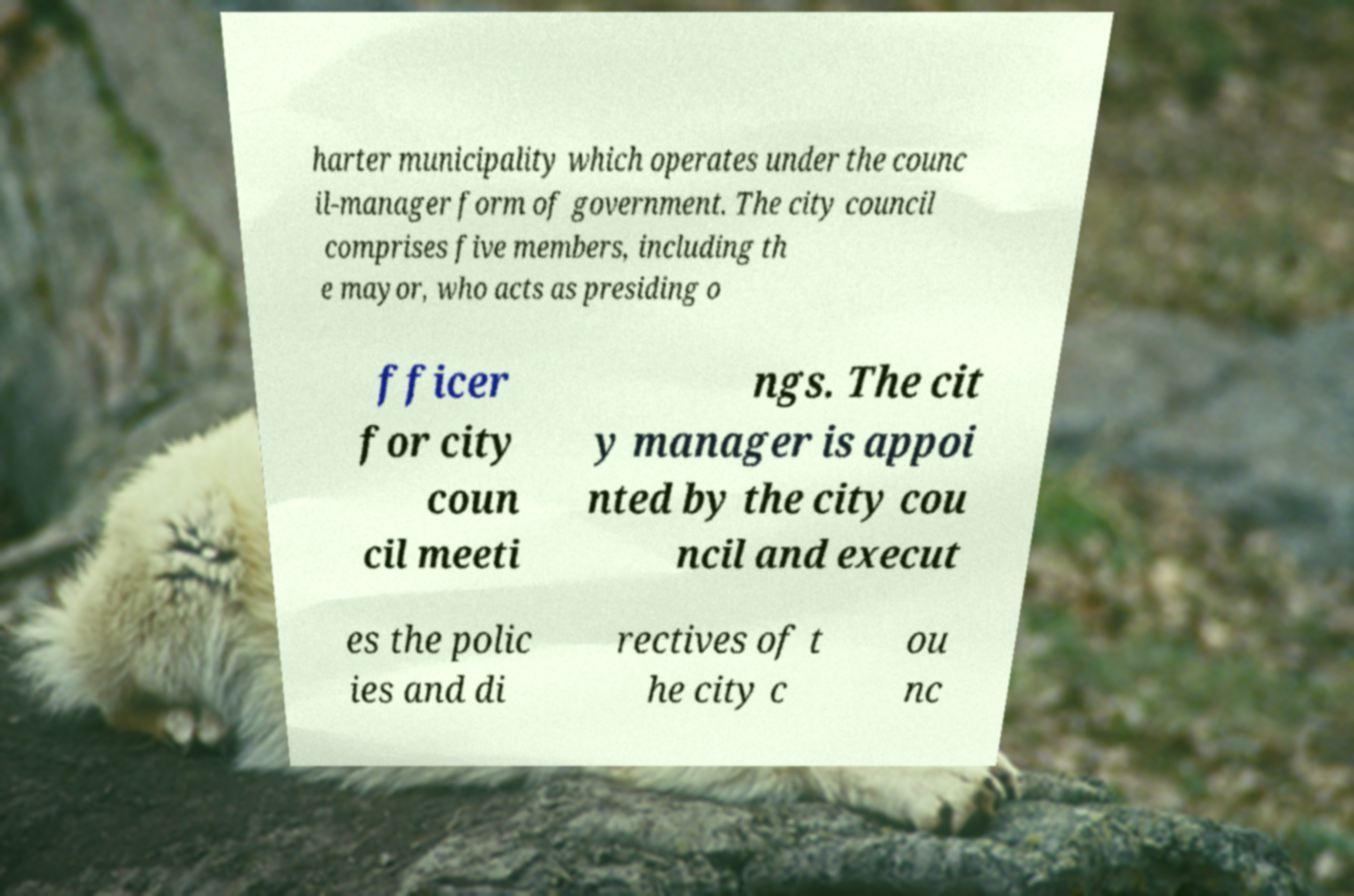Could you assist in decoding the text presented in this image and type it out clearly? harter municipality which operates under the counc il-manager form of government. The city council comprises five members, including th e mayor, who acts as presiding o fficer for city coun cil meeti ngs. The cit y manager is appoi nted by the city cou ncil and execut es the polic ies and di rectives of t he city c ou nc 